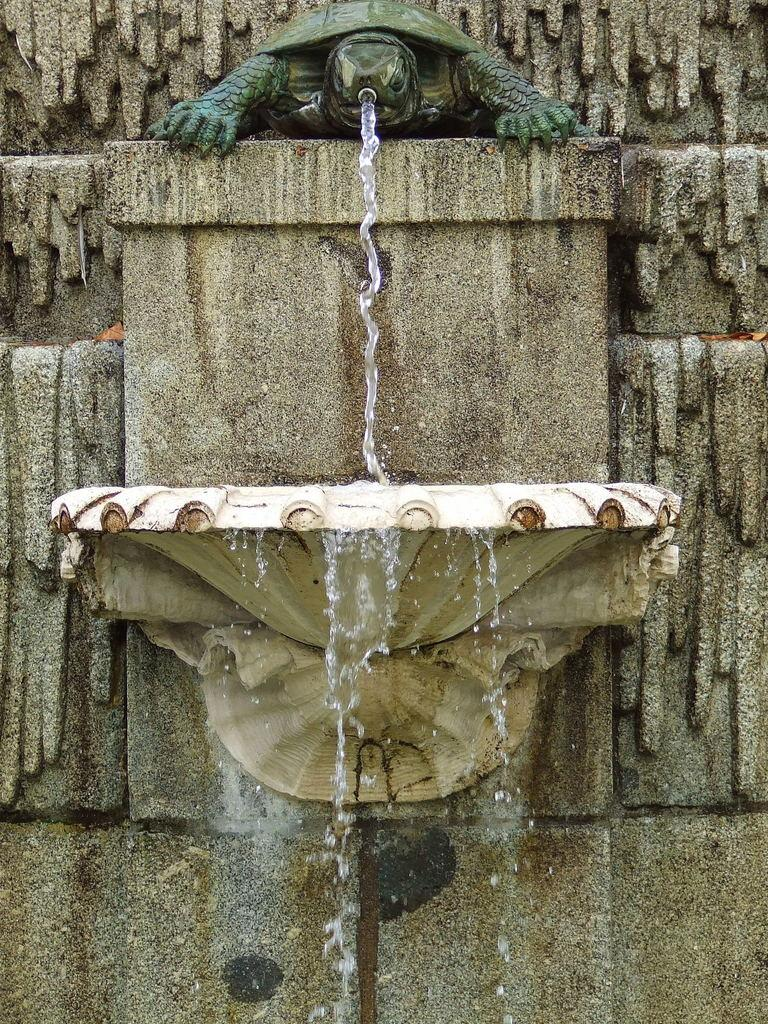What is the main subject of the image? There is a statue of a turtle in the image. What is the statue of the turtle doing? Water is flowing through the mouth of the turtle statue. What type of clover can be seen growing near the turtle statue in the image? There is no clover present in the image. How many bears are visible in the image? There are no bears present in the image. 